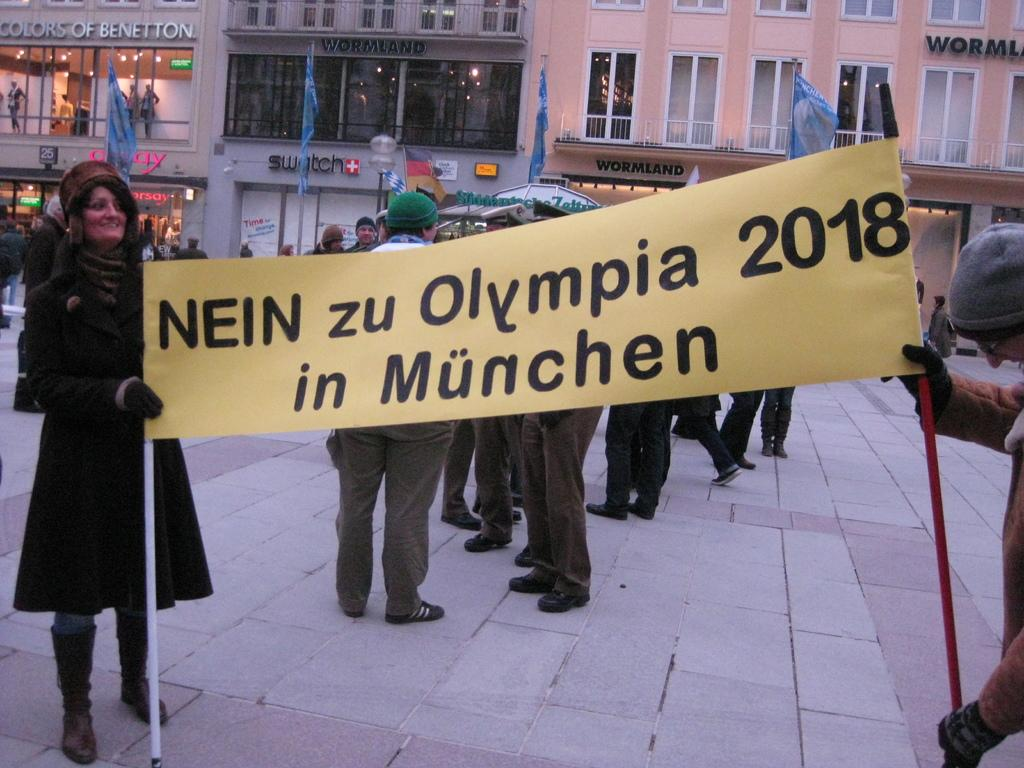What is hanging or displayed in the image? There is a banner in the image. Who or what can be seen in the image besides the banner? There are people and buildings in the image. What type of barrier or enclosure is present in the image? There is a fence in the image. What type of guide can be seen leading a group of people near the tent in the image? There is no guide or tent present in the image. The conversation focuses on the banner, people, buildings, and fence, as mentioned in the facts. 